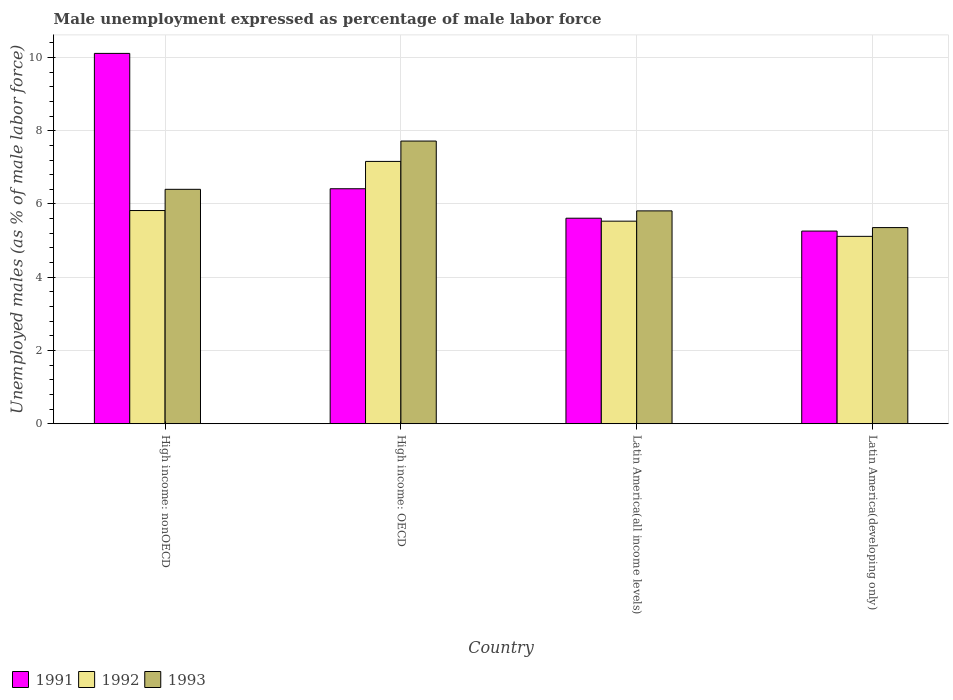Are the number of bars per tick equal to the number of legend labels?
Keep it short and to the point. Yes. Are the number of bars on each tick of the X-axis equal?
Ensure brevity in your answer.  Yes. How many bars are there on the 2nd tick from the left?
Offer a very short reply. 3. What is the label of the 3rd group of bars from the left?
Ensure brevity in your answer.  Latin America(all income levels). What is the unemployment in males in in 1993 in Latin America(all income levels)?
Your answer should be very brief. 5.81. Across all countries, what is the maximum unemployment in males in in 1993?
Make the answer very short. 7.72. Across all countries, what is the minimum unemployment in males in in 1993?
Ensure brevity in your answer.  5.36. In which country was the unemployment in males in in 1991 maximum?
Offer a very short reply. High income: nonOECD. In which country was the unemployment in males in in 1992 minimum?
Your answer should be very brief. Latin America(developing only). What is the total unemployment in males in in 1992 in the graph?
Give a very brief answer. 23.63. What is the difference between the unemployment in males in in 1992 in High income: OECD and that in High income: nonOECD?
Your answer should be compact. 1.34. What is the difference between the unemployment in males in in 1993 in Latin America(developing only) and the unemployment in males in in 1991 in High income: nonOECD?
Make the answer very short. -4.76. What is the average unemployment in males in in 1991 per country?
Offer a very short reply. 6.85. What is the difference between the unemployment in males in of/in 1993 and unemployment in males in of/in 1991 in Latin America(developing only)?
Give a very brief answer. 0.09. What is the ratio of the unemployment in males in in 1993 in High income: OECD to that in Latin America(all income levels)?
Your answer should be very brief. 1.33. Is the difference between the unemployment in males in in 1993 in High income: OECD and Latin America(developing only) greater than the difference between the unemployment in males in in 1991 in High income: OECD and Latin America(developing only)?
Keep it short and to the point. Yes. What is the difference between the highest and the second highest unemployment in males in in 1991?
Your response must be concise. 4.5. What is the difference between the highest and the lowest unemployment in males in in 1992?
Offer a terse response. 2.05. Is the sum of the unemployment in males in in 1992 in High income: nonOECD and Latin America(all income levels) greater than the maximum unemployment in males in in 1991 across all countries?
Provide a short and direct response. Yes. What does the 1st bar from the left in High income: nonOECD represents?
Your answer should be very brief. 1991. What does the 2nd bar from the right in High income: nonOECD represents?
Offer a terse response. 1992. Is it the case that in every country, the sum of the unemployment in males in in 1993 and unemployment in males in in 1992 is greater than the unemployment in males in in 1991?
Give a very brief answer. Yes. How many bars are there?
Your answer should be compact. 12. Are all the bars in the graph horizontal?
Your answer should be compact. No. What is the difference between two consecutive major ticks on the Y-axis?
Your response must be concise. 2. Does the graph contain grids?
Keep it short and to the point. Yes. Where does the legend appear in the graph?
Provide a short and direct response. Bottom left. How many legend labels are there?
Give a very brief answer. 3. How are the legend labels stacked?
Keep it short and to the point. Horizontal. What is the title of the graph?
Offer a very short reply. Male unemployment expressed as percentage of male labor force. What is the label or title of the Y-axis?
Provide a succinct answer. Unemployed males (as % of male labor force). What is the Unemployed males (as % of male labor force) of 1991 in High income: nonOECD?
Keep it short and to the point. 10.11. What is the Unemployed males (as % of male labor force) in 1992 in High income: nonOECD?
Provide a short and direct response. 5.82. What is the Unemployed males (as % of male labor force) in 1993 in High income: nonOECD?
Offer a terse response. 6.4. What is the Unemployed males (as % of male labor force) in 1991 in High income: OECD?
Make the answer very short. 6.42. What is the Unemployed males (as % of male labor force) in 1992 in High income: OECD?
Offer a very short reply. 7.16. What is the Unemployed males (as % of male labor force) of 1993 in High income: OECD?
Ensure brevity in your answer.  7.72. What is the Unemployed males (as % of male labor force) in 1991 in Latin America(all income levels)?
Your answer should be compact. 5.61. What is the Unemployed males (as % of male labor force) of 1992 in Latin America(all income levels)?
Give a very brief answer. 5.53. What is the Unemployed males (as % of male labor force) of 1993 in Latin America(all income levels)?
Give a very brief answer. 5.81. What is the Unemployed males (as % of male labor force) in 1991 in Latin America(developing only)?
Your response must be concise. 5.26. What is the Unemployed males (as % of male labor force) of 1992 in Latin America(developing only)?
Ensure brevity in your answer.  5.12. What is the Unemployed males (as % of male labor force) in 1993 in Latin America(developing only)?
Offer a very short reply. 5.36. Across all countries, what is the maximum Unemployed males (as % of male labor force) of 1991?
Provide a succinct answer. 10.11. Across all countries, what is the maximum Unemployed males (as % of male labor force) of 1992?
Keep it short and to the point. 7.16. Across all countries, what is the maximum Unemployed males (as % of male labor force) in 1993?
Provide a succinct answer. 7.72. Across all countries, what is the minimum Unemployed males (as % of male labor force) in 1991?
Offer a terse response. 5.26. Across all countries, what is the minimum Unemployed males (as % of male labor force) in 1992?
Your answer should be compact. 5.12. Across all countries, what is the minimum Unemployed males (as % of male labor force) of 1993?
Your answer should be compact. 5.36. What is the total Unemployed males (as % of male labor force) in 1991 in the graph?
Your response must be concise. 27.4. What is the total Unemployed males (as % of male labor force) of 1992 in the graph?
Offer a terse response. 23.63. What is the total Unemployed males (as % of male labor force) in 1993 in the graph?
Ensure brevity in your answer.  25.29. What is the difference between the Unemployed males (as % of male labor force) in 1991 in High income: nonOECD and that in High income: OECD?
Offer a terse response. 3.7. What is the difference between the Unemployed males (as % of male labor force) of 1992 in High income: nonOECD and that in High income: OECD?
Offer a very short reply. -1.34. What is the difference between the Unemployed males (as % of male labor force) in 1993 in High income: nonOECD and that in High income: OECD?
Offer a terse response. -1.32. What is the difference between the Unemployed males (as % of male labor force) in 1991 in High income: nonOECD and that in Latin America(all income levels)?
Your answer should be compact. 4.5. What is the difference between the Unemployed males (as % of male labor force) in 1992 in High income: nonOECD and that in Latin America(all income levels)?
Provide a succinct answer. 0.29. What is the difference between the Unemployed males (as % of male labor force) of 1993 in High income: nonOECD and that in Latin America(all income levels)?
Give a very brief answer. 0.59. What is the difference between the Unemployed males (as % of male labor force) of 1991 in High income: nonOECD and that in Latin America(developing only)?
Offer a terse response. 4.85. What is the difference between the Unemployed males (as % of male labor force) of 1992 in High income: nonOECD and that in Latin America(developing only)?
Offer a very short reply. 0.7. What is the difference between the Unemployed males (as % of male labor force) of 1993 in High income: nonOECD and that in Latin America(developing only)?
Give a very brief answer. 1.04. What is the difference between the Unemployed males (as % of male labor force) of 1991 in High income: OECD and that in Latin America(all income levels)?
Your answer should be compact. 0.8. What is the difference between the Unemployed males (as % of male labor force) in 1992 in High income: OECD and that in Latin America(all income levels)?
Provide a short and direct response. 1.63. What is the difference between the Unemployed males (as % of male labor force) in 1993 in High income: OECD and that in Latin America(all income levels)?
Your answer should be compact. 1.91. What is the difference between the Unemployed males (as % of male labor force) of 1991 in High income: OECD and that in Latin America(developing only)?
Keep it short and to the point. 1.16. What is the difference between the Unemployed males (as % of male labor force) in 1992 in High income: OECD and that in Latin America(developing only)?
Make the answer very short. 2.05. What is the difference between the Unemployed males (as % of male labor force) in 1993 in High income: OECD and that in Latin America(developing only)?
Your answer should be very brief. 2.36. What is the difference between the Unemployed males (as % of male labor force) in 1991 in Latin America(all income levels) and that in Latin America(developing only)?
Ensure brevity in your answer.  0.35. What is the difference between the Unemployed males (as % of male labor force) in 1992 in Latin America(all income levels) and that in Latin America(developing only)?
Provide a succinct answer. 0.41. What is the difference between the Unemployed males (as % of male labor force) in 1993 in Latin America(all income levels) and that in Latin America(developing only)?
Provide a succinct answer. 0.46. What is the difference between the Unemployed males (as % of male labor force) of 1991 in High income: nonOECD and the Unemployed males (as % of male labor force) of 1992 in High income: OECD?
Offer a terse response. 2.95. What is the difference between the Unemployed males (as % of male labor force) of 1991 in High income: nonOECD and the Unemployed males (as % of male labor force) of 1993 in High income: OECD?
Offer a terse response. 2.39. What is the difference between the Unemployed males (as % of male labor force) of 1992 in High income: nonOECD and the Unemployed males (as % of male labor force) of 1993 in High income: OECD?
Make the answer very short. -1.9. What is the difference between the Unemployed males (as % of male labor force) of 1991 in High income: nonOECD and the Unemployed males (as % of male labor force) of 1992 in Latin America(all income levels)?
Keep it short and to the point. 4.58. What is the difference between the Unemployed males (as % of male labor force) of 1991 in High income: nonOECD and the Unemployed males (as % of male labor force) of 1993 in Latin America(all income levels)?
Keep it short and to the point. 4.3. What is the difference between the Unemployed males (as % of male labor force) in 1992 in High income: nonOECD and the Unemployed males (as % of male labor force) in 1993 in Latin America(all income levels)?
Your answer should be compact. 0.01. What is the difference between the Unemployed males (as % of male labor force) of 1991 in High income: nonOECD and the Unemployed males (as % of male labor force) of 1992 in Latin America(developing only)?
Offer a very short reply. 5. What is the difference between the Unemployed males (as % of male labor force) in 1991 in High income: nonOECD and the Unemployed males (as % of male labor force) in 1993 in Latin America(developing only)?
Offer a terse response. 4.76. What is the difference between the Unemployed males (as % of male labor force) in 1992 in High income: nonOECD and the Unemployed males (as % of male labor force) in 1993 in Latin America(developing only)?
Your answer should be compact. 0.47. What is the difference between the Unemployed males (as % of male labor force) of 1991 in High income: OECD and the Unemployed males (as % of male labor force) of 1992 in Latin America(all income levels)?
Offer a terse response. 0.89. What is the difference between the Unemployed males (as % of male labor force) of 1991 in High income: OECD and the Unemployed males (as % of male labor force) of 1993 in Latin America(all income levels)?
Provide a short and direct response. 0.6. What is the difference between the Unemployed males (as % of male labor force) in 1992 in High income: OECD and the Unemployed males (as % of male labor force) in 1993 in Latin America(all income levels)?
Your answer should be very brief. 1.35. What is the difference between the Unemployed males (as % of male labor force) in 1991 in High income: OECD and the Unemployed males (as % of male labor force) in 1992 in Latin America(developing only)?
Provide a short and direct response. 1.3. What is the difference between the Unemployed males (as % of male labor force) in 1991 in High income: OECD and the Unemployed males (as % of male labor force) in 1993 in Latin America(developing only)?
Your response must be concise. 1.06. What is the difference between the Unemployed males (as % of male labor force) of 1992 in High income: OECD and the Unemployed males (as % of male labor force) of 1993 in Latin America(developing only)?
Ensure brevity in your answer.  1.81. What is the difference between the Unemployed males (as % of male labor force) of 1991 in Latin America(all income levels) and the Unemployed males (as % of male labor force) of 1992 in Latin America(developing only)?
Offer a terse response. 0.5. What is the difference between the Unemployed males (as % of male labor force) of 1991 in Latin America(all income levels) and the Unemployed males (as % of male labor force) of 1993 in Latin America(developing only)?
Provide a succinct answer. 0.26. What is the difference between the Unemployed males (as % of male labor force) of 1992 in Latin America(all income levels) and the Unemployed males (as % of male labor force) of 1993 in Latin America(developing only)?
Ensure brevity in your answer.  0.18. What is the average Unemployed males (as % of male labor force) of 1991 per country?
Your response must be concise. 6.85. What is the average Unemployed males (as % of male labor force) in 1992 per country?
Provide a short and direct response. 5.91. What is the average Unemployed males (as % of male labor force) in 1993 per country?
Offer a very short reply. 6.32. What is the difference between the Unemployed males (as % of male labor force) in 1991 and Unemployed males (as % of male labor force) in 1992 in High income: nonOECD?
Make the answer very short. 4.29. What is the difference between the Unemployed males (as % of male labor force) in 1991 and Unemployed males (as % of male labor force) in 1993 in High income: nonOECD?
Provide a short and direct response. 3.71. What is the difference between the Unemployed males (as % of male labor force) of 1992 and Unemployed males (as % of male labor force) of 1993 in High income: nonOECD?
Your answer should be compact. -0.58. What is the difference between the Unemployed males (as % of male labor force) of 1991 and Unemployed males (as % of male labor force) of 1992 in High income: OECD?
Offer a terse response. -0.75. What is the difference between the Unemployed males (as % of male labor force) of 1991 and Unemployed males (as % of male labor force) of 1993 in High income: OECD?
Provide a succinct answer. -1.3. What is the difference between the Unemployed males (as % of male labor force) of 1992 and Unemployed males (as % of male labor force) of 1993 in High income: OECD?
Provide a short and direct response. -0.56. What is the difference between the Unemployed males (as % of male labor force) in 1991 and Unemployed males (as % of male labor force) in 1992 in Latin America(all income levels)?
Make the answer very short. 0.08. What is the difference between the Unemployed males (as % of male labor force) of 1991 and Unemployed males (as % of male labor force) of 1993 in Latin America(all income levels)?
Your answer should be compact. -0.2. What is the difference between the Unemployed males (as % of male labor force) in 1992 and Unemployed males (as % of male labor force) in 1993 in Latin America(all income levels)?
Your answer should be compact. -0.28. What is the difference between the Unemployed males (as % of male labor force) in 1991 and Unemployed males (as % of male labor force) in 1992 in Latin America(developing only)?
Your response must be concise. 0.14. What is the difference between the Unemployed males (as % of male labor force) of 1991 and Unemployed males (as % of male labor force) of 1993 in Latin America(developing only)?
Your answer should be compact. -0.1. What is the difference between the Unemployed males (as % of male labor force) in 1992 and Unemployed males (as % of male labor force) in 1993 in Latin America(developing only)?
Your answer should be very brief. -0.24. What is the ratio of the Unemployed males (as % of male labor force) in 1991 in High income: nonOECD to that in High income: OECD?
Your answer should be very brief. 1.58. What is the ratio of the Unemployed males (as % of male labor force) of 1992 in High income: nonOECD to that in High income: OECD?
Your answer should be compact. 0.81. What is the ratio of the Unemployed males (as % of male labor force) of 1993 in High income: nonOECD to that in High income: OECD?
Give a very brief answer. 0.83. What is the ratio of the Unemployed males (as % of male labor force) in 1991 in High income: nonOECD to that in Latin America(all income levels)?
Provide a short and direct response. 1.8. What is the ratio of the Unemployed males (as % of male labor force) in 1992 in High income: nonOECD to that in Latin America(all income levels)?
Make the answer very short. 1.05. What is the ratio of the Unemployed males (as % of male labor force) of 1993 in High income: nonOECD to that in Latin America(all income levels)?
Your response must be concise. 1.1. What is the ratio of the Unemployed males (as % of male labor force) of 1991 in High income: nonOECD to that in Latin America(developing only)?
Your response must be concise. 1.92. What is the ratio of the Unemployed males (as % of male labor force) of 1992 in High income: nonOECD to that in Latin America(developing only)?
Provide a short and direct response. 1.14. What is the ratio of the Unemployed males (as % of male labor force) of 1993 in High income: nonOECD to that in Latin America(developing only)?
Provide a succinct answer. 1.2. What is the ratio of the Unemployed males (as % of male labor force) in 1991 in High income: OECD to that in Latin America(all income levels)?
Your answer should be very brief. 1.14. What is the ratio of the Unemployed males (as % of male labor force) of 1992 in High income: OECD to that in Latin America(all income levels)?
Offer a very short reply. 1.29. What is the ratio of the Unemployed males (as % of male labor force) of 1993 in High income: OECD to that in Latin America(all income levels)?
Your answer should be very brief. 1.33. What is the ratio of the Unemployed males (as % of male labor force) in 1991 in High income: OECD to that in Latin America(developing only)?
Your answer should be very brief. 1.22. What is the ratio of the Unemployed males (as % of male labor force) in 1992 in High income: OECD to that in Latin America(developing only)?
Keep it short and to the point. 1.4. What is the ratio of the Unemployed males (as % of male labor force) of 1993 in High income: OECD to that in Latin America(developing only)?
Your answer should be compact. 1.44. What is the ratio of the Unemployed males (as % of male labor force) of 1991 in Latin America(all income levels) to that in Latin America(developing only)?
Your response must be concise. 1.07. What is the ratio of the Unemployed males (as % of male labor force) in 1992 in Latin America(all income levels) to that in Latin America(developing only)?
Provide a succinct answer. 1.08. What is the ratio of the Unemployed males (as % of male labor force) in 1993 in Latin America(all income levels) to that in Latin America(developing only)?
Make the answer very short. 1.09. What is the difference between the highest and the second highest Unemployed males (as % of male labor force) of 1991?
Make the answer very short. 3.7. What is the difference between the highest and the second highest Unemployed males (as % of male labor force) in 1992?
Keep it short and to the point. 1.34. What is the difference between the highest and the second highest Unemployed males (as % of male labor force) in 1993?
Offer a terse response. 1.32. What is the difference between the highest and the lowest Unemployed males (as % of male labor force) in 1991?
Give a very brief answer. 4.85. What is the difference between the highest and the lowest Unemployed males (as % of male labor force) of 1992?
Give a very brief answer. 2.05. What is the difference between the highest and the lowest Unemployed males (as % of male labor force) in 1993?
Your answer should be compact. 2.36. 